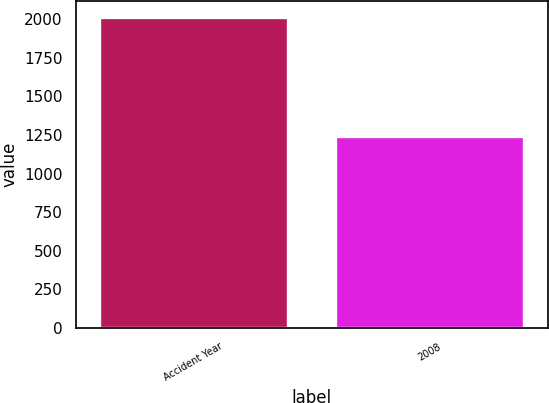<chart> <loc_0><loc_0><loc_500><loc_500><bar_chart><fcel>Accident Year<fcel>2008<nl><fcel>2017<fcel>1242<nl></chart> 